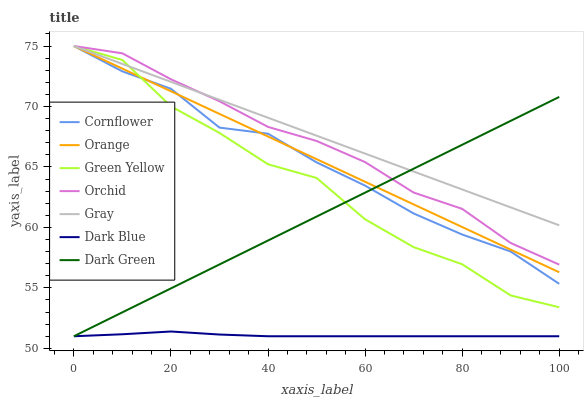Does Dark Green have the minimum area under the curve?
Answer yes or no. No. Does Dark Green have the maximum area under the curve?
Answer yes or no. No. Is Gray the smoothest?
Answer yes or no. No. Is Gray the roughest?
Answer yes or no. No. Does Gray have the lowest value?
Answer yes or no. No. Does Dark Green have the highest value?
Answer yes or no. No. Is Dark Blue less than Orange?
Answer yes or no. Yes. Is Gray greater than Dark Blue?
Answer yes or no. Yes. Does Dark Blue intersect Orange?
Answer yes or no. No. 